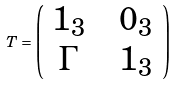<formula> <loc_0><loc_0><loc_500><loc_500>T = \left ( \begin{array} { c c c } 1 _ { 3 } & & 0 _ { 3 } \\ \Gamma & & 1 _ { 3 } \\ \end{array} \right )</formula> 